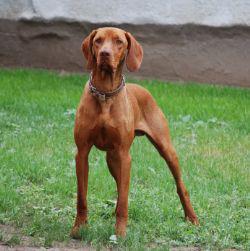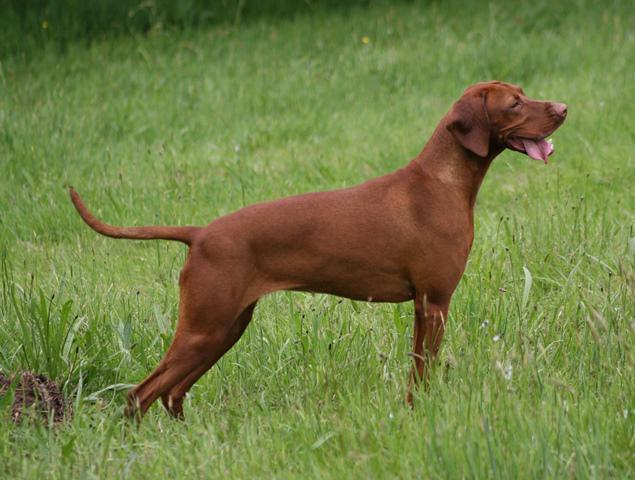The first image is the image on the left, the second image is the image on the right. Considering the images on both sides, is "Each image includes at least one red-orange dog in a standing pose, at least two adult dogs in total are shown, and no other poses are shown." valid? Answer yes or no. Yes. The first image is the image on the left, the second image is the image on the right. For the images displayed, is the sentence "There are two dogs." factually correct? Answer yes or no. Yes. 